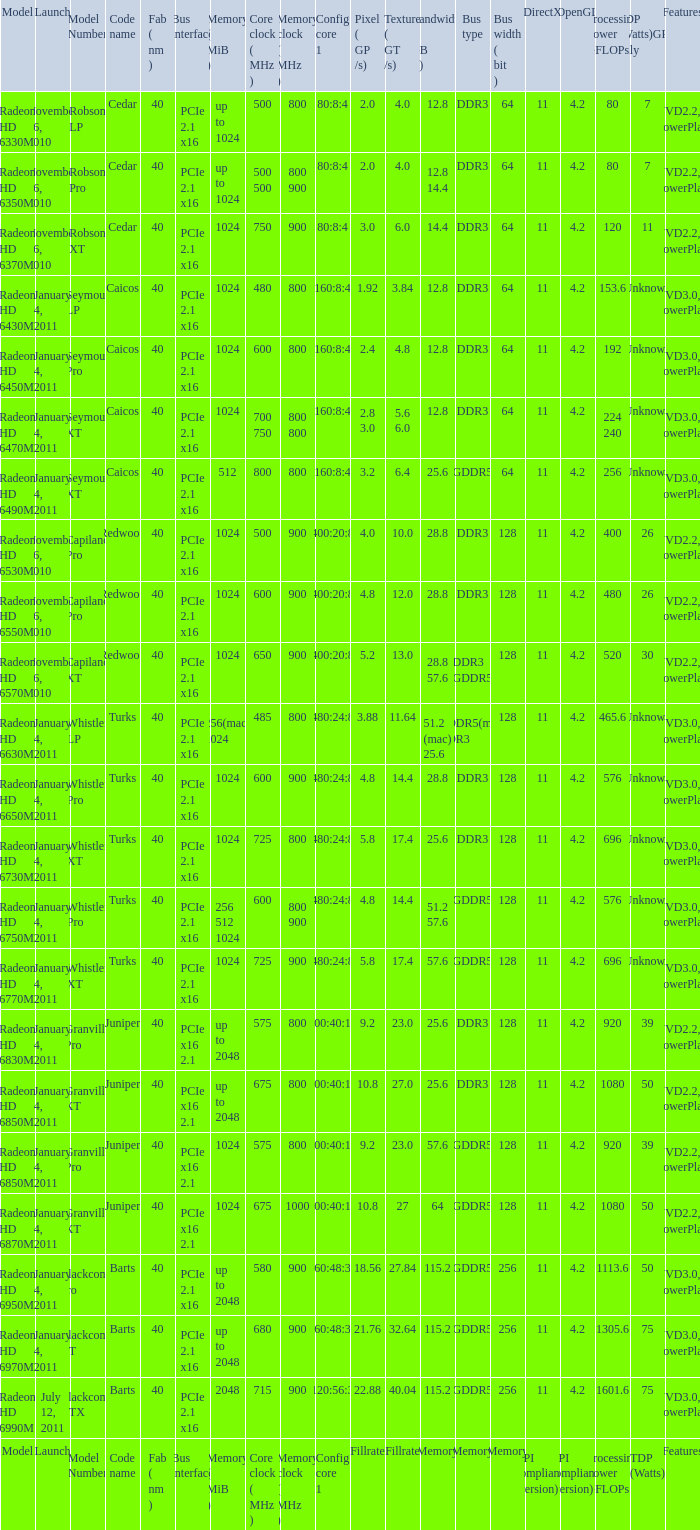Would you be able to parse every entry in this table? {'header': ['Model', 'Launch', 'Model Number', 'Code name', 'Fab ( nm )', 'Bus interface', 'Memory ( MiB )', 'Core clock ( MHz )', 'Memory clock ( MHz )', 'Config core 1', 'Pixel ( GP /s)', 'Texture ( GT /s)', 'Bandwidth ( GB /s)', 'Bus type', 'Bus width ( bit )', 'DirectX', 'OpenGL', 'Processing Power GFLOPs', 'TDP (Watts)GPU only', 'Features'], 'rows': [['Radeon HD 6330M', 'November 26, 2010', 'Robson LP', 'Cedar', '40', 'PCIe 2.1 x16', 'up to 1024', '500', '800', '80:8:4', '2.0', '4.0', '12.8', 'DDR3', '64', '11', '4.2', '80', '7', 'UVD2.2, PowerPlay'], ['Radeon HD 6350M', 'November 26, 2010', 'Robson Pro', 'Cedar', '40', 'PCIe 2.1 x16', 'up to 1024', '500 500', '800 900', '80:8:4', '2.0', '4.0', '12.8 14.4', 'DDR3', '64', '11', '4.2', '80', '7', 'UVD2.2, PowerPlay'], ['Radeon HD 6370M', 'November 26, 2010', 'Robson XT', 'Cedar', '40', 'PCIe 2.1 x16', '1024', '750', '900', '80:8:4', '3.0', '6.0', '14.4', 'DDR3', '64', '11', '4.2', '120', '11', 'UVD2.2, PowerPlay'], ['Radeon HD 6430M', 'January 4, 2011', 'Seymour LP', 'Caicos', '40', 'PCIe 2.1 x16', '1024', '480', '800', '160:8:4', '1.92', '3.84', '12.8', 'DDR3', '64', '11', '4.2', '153.6', 'Unknown', 'UVD3.0, PowerPlay'], ['Radeon HD 6450M', 'January 4, 2011', 'Seymour Pro', 'Caicos', '40', 'PCIe 2.1 x16', '1024', '600', '800', '160:8:4', '2.4', '4.8', '12.8', 'DDR3', '64', '11', '4.2', '192', 'Unknown', 'UVD3.0, PowerPlay'], ['Radeon HD 6470M', 'January 4, 2011', 'Seymour XT', 'Caicos', '40', 'PCIe 2.1 x16', '1024', '700 750', '800 800', '160:8:4', '2.8 3.0', '5.6 6.0', '12.8', 'DDR3', '64', '11', '4.2', '224 240', 'Unknown', 'UVD3.0, PowerPlay'], ['Radeon HD 6490M', 'January 4, 2011', 'Seymour XT', 'Caicos', '40', 'PCIe 2.1 x16', '512', '800', '800', '160:8:4', '3.2', '6.4', '25.6', 'GDDR5', '64', '11', '4.2', '256', 'Unknown', 'UVD3.0, PowerPlay'], ['Radeon HD 6530M', 'November 26, 2010', 'Capilano Pro', 'Redwood', '40', 'PCIe 2.1 x16', '1024', '500', '900', '400:20:8', '4.0', '10.0', '28.8', 'DDR3', '128', '11', '4.2', '400', '26', 'UVD2.2, PowerPlay'], ['Radeon HD 6550M', 'November 26, 2010', 'Capilano Pro', 'Redwood', '40', 'PCIe 2.1 x16', '1024', '600', '900', '400:20:8', '4.8', '12.0', '28.8', 'DDR3', '128', '11', '4.2', '480', '26', 'UVD2.2, PowerPlay'], ['Radeon HD 6570M', 'November 26, 2010', 'Capilano XT', 'Redwood', '40', 'PCIe 2.1 x16', '1024', '650', '900', '400:20:8', '5.2', '13.0', '28.8 57.6', 'DDR3 GDDR5', '128', '11', '4.2', '520', '30', 'UVD2.2, PowerPlay'], ['Radeon HD 6630M', 'January 4, 2011', 'Whistler LP', 'Turks', '40', 'PCIe 2.1 x16', '256(mac) 1024', '485', '800', '480:24:8', '3.88', '11.64', '51.2 (mac) 25.6', 'GDDR5(mac) DDR3', '128', '11', '4.2', '465.6', 'Unknown', 'UVD3.0, PowerPlay'], ['Radeon HD 6650M', 'January 4, 2011', 'Whistler Pro', 'Turks', '40', 'PCIe 2.1 x16', '1024', '600', '900', '480:24:8', '4.8', '14.4', '28.8', 'DDR3', '128', '11', '4.2', '576', 'Unknown', 'UVD3.0, PowerPlay'], ['Radeon HD 6730M', 'January 4, 2011', 'Whistler XT', 'Turks', '40', 'PCIe 2.1 x16', '1024', '725', '800', '480:24:8', '5.8', '17.4', '25.6', 'DDR3', '128', '11', '4.2', '696', 'Unknown', 'UVD3.0, PowerPlay'], ['Radeon HD 6750M', 'January 4, 2011', 'Whistler Pro', 'Turks', '40', 'PCIe 2.1 x16', '256 512 1024', '600', '800 900', '480:24:8', '4.8', '14.4', '51.2 57.6', 'GDDR5', '128', '11', '4.2', '576', 'Unknown', 'UVD3.0, PowerPlay'], ['Radeon HD 6770M', 'January 4, 2011', 'Whistler XT', 'Turks', '40', 'PCIe 2.1 x16', '1024', '725', '900', '480:24:8', '5.8', '17.4', '57.6', 'GDDR5', '128', '11', '4.2', '696', 'Unknown', 'UVD3.0, PowerPlay'], ['Radeon HD 6830M', 'January 4, 2011', 'Granville Pro', 'Juniper', '40', 'PCIe x16 2.1', 'up to 2048', '575', '800', '800:40:16', '9.2', '23.0', '25.6', 'DDR3', '128', '11', '4.2', '920', '39', 'UVD2.2, PowerPlay'], ['Radeon HD 6850M', 'January 4, 2011', 'Granville XT', 'Juniper', '40', 'PCIe x16 2.1', 'up to 2048', '675', '800', '800:40:16', '10.8', '27.0', '25.6', 'DDR3', '128', '11', '4.2', '1080', '50', 'UVD2.2, PowerPlay'], ['Radeon HD 6850M', 'January 4, 2011', 'Granville Pro', 'Juniper', '40', 'PCIe x16 2.1', '1024', '575', '800', '800:40:16', '9.2', '23.0', '57.6', 'GDDR5', '128', '11', '4.2', '920', '39', 'UVD2.2, PowerPlay'], ['Radeon HD 6870M', 'January 4, 2011', 'Granville XT', 'Juniper', '40', 'PCIe x16 2.1', '1024', '675', '1000', '800:40:16', '10.8', '27', '64', 'GDDR5', '128', '11', '4.2', '1080', '50', 'UVD2.2, PowerPlay'], ['Radeon HD 6950M', 'January 4, 2011', 'Blackcomb Pro', 'Barts', '40', 'PCIe 2.1 x16', 'up to 2048', '580', '900', '960:48:32', '18.56', '27.84', '115.2', 'GDDR5', '256', '11', '4.2', '1113.6', '50', 'UVD3.0, PowerPlay'], ['Radeon HD 6970M', 'January 4, 2011', 'Blackcomb XT', 'Barts', '40', 'PCIe 2.1 x16', 'up to 2048', '680', '900', '960:48:32', '21.76', '32.64', '115.2', 'GDDR5', '256', '11', '4.2', '1305.6', '75', 'UVD3.0, PowerPlay'], ['Radeon HD 6990M', 'July 12, 2011', 'Blackcomb XTX', 'Barts', '40', 'PCIe 2.1 x16', '2048', '715', '900', '1120:56:32', '22.88', '40.04', '115.2', 'GDDR5', '256', '11', '4.2', '1601.6', '75', 'UVD3.0, PowerPlay'], ['Model', 'Launch', 'Model Number', 'Code name', 'Fab ( nm )', 'Bus interface', 'Memory ( MiB )', 'Core clock ( MHz )', 'Memory clock ( MHz )', 'Config core 1', 'Fillrate', 'Fillrate', 'Memory', 'Memory', 'Memory', 'API compliance (version)', 'API compliance (version)', 'Processing Power GFLOPs', 'TDP (Watts)', 'Features']]} What is the amount for congi core 1 if the code name is redwood and core clock(mhz) is 500? 400:20:8. 